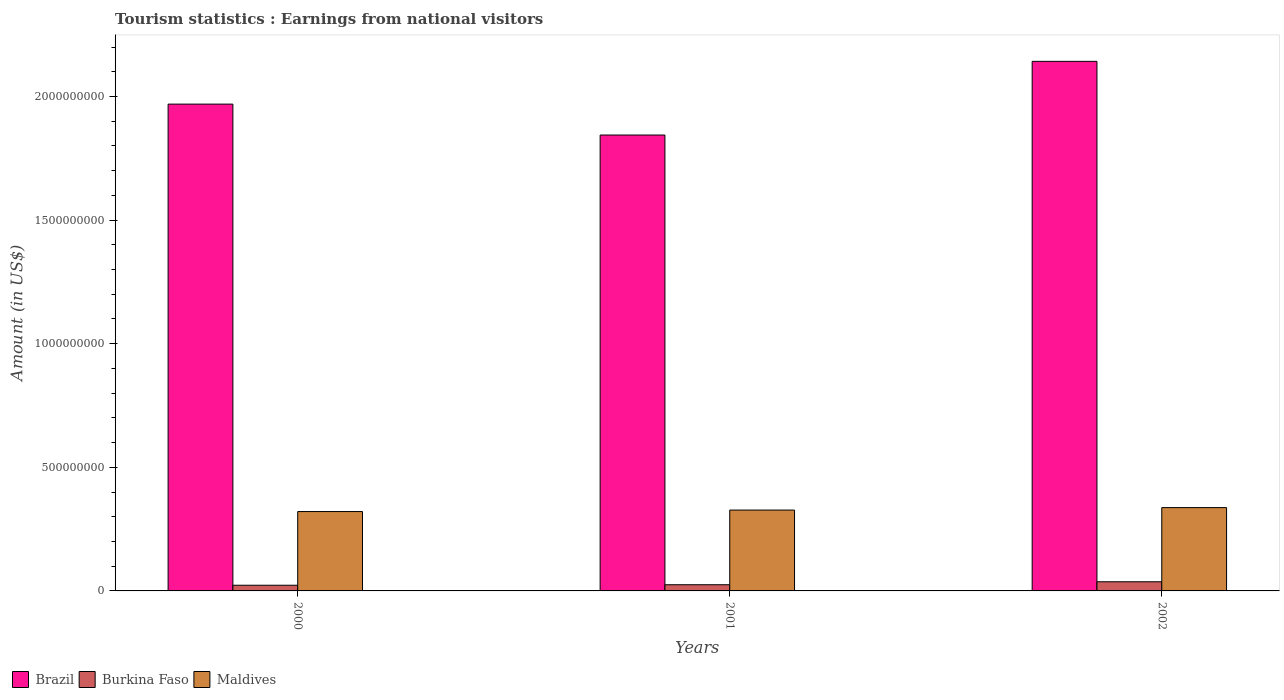How many different coloured bars are there?
Ensure brevity in your answer.  3. Are the number of bars on each tick of the X-axis equal?
Offer a terse response. Yes. How many bars are there on the 1st tick from the right?
Give a very brief answer. 3. What is the label of the 1st group of bars from the left?
Offer a terse response. 2000. In how many cases, is the number of bars for a given year not equal to the number of legend labels?
Make the answer very short. 0. What is the earnings from national visitors in Brazil in 2000?
Provide a succinct answer. 1.97e+09. Across all years, what is the maximum earnings from national visitors in Burkina Faso?
Provide a succinct answer. 3.70e+07. Across all years, what is the minimum earnings from national visitors in Maldives?
Your response must be concise. 3.21e+08. In which year was the earnings from national visitors in Brazil minimum?
Offer a very short reply. 2001. What is the total earnings from national visitors in Maldives in the graph?
Your answer should be very brief. 9.85e+08. What is the difference between the earnings from national visitors in Burkina Faso in 2000 and that in 2002?
Your answer should be very brief. -1.40e+07. What is the difference between the earnings from national visitors in Burkina Faso in 2000 and the earnings from national visitors in Brazil in 2002?
Make the answer very short. -2.12e+09. What is the average earnings from national visitors in Burkina Faso per year?
Offer a very short reply. 2.83e+07. In the year 2001, what is the difference between the earnings from national visitors in Maldives and earnings from national visitors in Brazil?
Give a very brief answer. -1.52e+09. In how many years, is the earnings from national visitors in Burkina Faso greater than 600000000 US$?
Keep it short and to the point. 0. What is the ratio of the earnings from national visitors in Brazil in 2000 to that in 2001?
Give a very brief answer. 1.07. Is the difference between the earnings from national visitors in Maldives in 2000 and 2002 greater than the difference between the earnings from national visitors in Brazil in 2000 and 2002?
Your response must be concise. Yes. What is the difference between the highest and the second highest earnings from national visitors in Brazil?
Make the answer very short. 1.73e+08. What is the difference between the highest and the lowest earnings from national visitors in Burkina Faso?
Provide a succinct answer. 1.40e+07. What does the 1st bar from the right in 2002 represents?
Provide a short and direct response. Maldives. How many years are there in the graph?
Make the answer very short. 3. What is the difference between two consecutive major ticks on the Y-axis?
Ensure brevity in your answer.  5.00e+08. How many legend labels are there?
Keep it short and to the point. 3. What is the title of the graph?
Ensure brevity in your answer.  Tourism statistics : Earnings from national visitors. What is the label or title of the Y-axis?
Ensure brevity in your answer.  Amount (in US$). What is the Amount (in US$) of Brazil in 2000?
Provide a short and direct response. 1.97e+09. What is the Amount (in US$) in Burkina Faso in 2000?
Your response must be concise. 2.30e+07. What is the Amount (in US$) in Maldives in 2000?
Ensure brevity in your answer.  3.21e+08. What is the Amount (in US$) in Brazil in 2001?
Ensure brevity in your answer.  1.84e+09. What is the Amount (in US$) of Burkina Faso in 2001?
Keep it short and to the point. 2.50e+07. What is the Amount (in US$) in Maldives in 2001?
Provide a succinct answer. 3.27e+08. What is the Amount (in US$) of Brazil in 2002?
Your answer should be compact. 2.14e+09. What is the Amount (in US$) of Burkina Faso in 2002?
Make the answer very short. 3.70e+07. What is the Amount (in US$) of Maldives in 2002?
Keep it short and to the point. 3.37e+08. Across all years, what is the maximum Amount (in US$) in Brazil?
Your response must be concise. 2.14e+09. Across all years, what is the maximum Amount (in US$) of Burkina Faso?
Make the answer very short. 3.70e+07. Across all years, what is the maximum Amount (in US$) of Maldives?
Offer a terse response. 3.37e+08. Across all years, what is the minimum Amount (in US$) in Brazil?
Your response must be concise. 1.84e+09. Across all years, what is the minimum Amount (in US$) of Burkina Faso?
Ensure brevity in your answer.  2.30e+07. Across all years, what is the minimum Amount (in US$) in Maldives?
Offer a very short reply. 3.21e+08. What is the total Amount (in US$) of Brazil in the graph?
Your response must be concise. 5.96e+09. What is the total Amount (in US$) of Burkina Faso in the graph?
Provide a short and direct response. 8.50e+07. What is the total Amount (in US$) in Maldives in the graph?
Provide a succinct answer. 9.85e+08. What is the difference between the Amount (in US$) in Brazil in 2000 and that in 2001?
Your response must be concise. 1.25e+08. What is the difference between the Amount (in US$) of Burkina Faso in 2000 and that in 2001?
Offer a terse response. -2.00e+06. What is the difference between the Amount (in US$) of Maldives in 2000 and that in 2001?
Give a very brief answer. -6.00e+06. What is the difference between the Amount (in US$) in Brazil in 2000 and that in 2002?
Give a very brief answer. -1.73e+08. What is the difference between the Amount (in US$) in Burkina Faso in 2000 and that in 2002?
Your response must be concise. -1.40e+07. What is the difference between the Amount (in US$) in Maldives in 2000 and that in 2002?
Make the answer very short. -1.60e+07. What is the difference between the Amount (in US$) of Brazil in 2001 and that in 2002?
Your answer should be very brief. -2.98e+08. What is the difference between the Amount (in US$) of Burkina Faso in 2001 and that in 2002?
Ensure brevity in your answer.  -1.20e+07. What is the difference between the Amount (in US$) in Maldives in 2001 and that in 2002?
Offer a terse response. -1.00e+07. What is the difference between the Amount (in US$) in Brazil in 2000 and the Amount (in US$) in Burkina Faso in 2001?
Keep it short and to the point. 1.94e+09. What is the difference between the Amount (in US$) in Brazil in 2000 and the Amount (in US$) in Maldives in 2001?
Your answer should be very brief. 1.64e+09. What is the difference between the Amount (in US$) in Burkina Faso in 2000 and the Amount (in US$) in Maldives in 2001?
Your response must be concise. -3.04e+08. What is the difference between the Amount (in US$) of Brazil in 2000 and the Amount (in US$) of Burkina Faso in 2002?
Make the answer very short. 1.93e+09. What is the difference between the Amount (in US$) of Brazil in 2000 and the Amount (in US$) of Maldives in 2002?
Provide a succinct answer. 1.63e+09. What is the difference between the Amount (in US$) of Burkina Faso in 2000 and the Amount (in US$) of Maldives in 2002?
Keep it short and to the point. -3.14e+08. What is the difference between the Amount (in US$) in Brazil in 2001 and the Amount (in US$) in Burkina Faso in 2002?
Make the answer very short. 1.81e+09. What is the difference between the Amount (in US$) of Brazil in 2001 and the Amount (in US$) of Maldives in 2002?
Ensure brevity in your answer.  1.51e+09. What is the difference between the Amount (in US$) of Burkina Faso in 2001 and the Amount (in US$) of Maldives in 2002?
Your response must be concise. -3.12e+08. What is the average Amount (in US$) in Brazil per year?
Keep it short and to the point. 1.98e+09. What is the average Amount (in US$) in Burkina Faso per year?
Provide a short and direct response. 2.83e+07. What is the average Amount (in US$) of Maldives per year?
Make the answer very short. 3.28e+08. In the year 2000, what is the difference between the Amount (in US$) in Brazil and Amount (in US$) in Burkina Faso?
Make the answer very short. 1.95e+09. In the year 2000, what is the difference between the Amount (in US$) in Brazil and Amount (in US$) in Maldives?
Ensure brevity in your answer.  1.65e+09. In the year 2000, what is the difference between the Amount (in US$) of Burkina Faso and Amount (in US$) of Maldives?
Keep it short and to the point. -2.98e+08. In the year 2001, what is the difference between the Amount (in US$) in Brazil and Amount (in US$) in Burkina Faso?
Provide a succinct answer. 1.82e+09. In the year 2001, what is the difference between the Amount (in US$) in Brazil and Amount (in US$) in Maldives?
Provide a succinct answer. 1.52e+09. In the year 2001, what is the difference between the Amount (in US$) of Burkina Faso and Amount (in US$) of Maldives?
Ensure brevity in your answer.  -3.02e+08. In the year 2002, what is the difference between the Amount (in US$) in Brazil and Amount (in US$) in Burkina Faso?
Offer a very short reply. 2.10e+09. In the year 2002, what is the difference between the Amount (in US$) in Brazil and Amount (in US$) in Maldives?
Offer a terse response. 1.80e+09. In the year 2002, what is the difference between the Amount (in US$) of Burkina Faso and Amount (in US$) of Maldives?
Provide a succinct answer. -3.00e+08. What is the ratio of the Amount (in US$) in Brazil in 2000 to that in 2001?
Your answer should be very brief. 1.07. What is the ratio of the Amount (in US$) of Burkina Faso in 2000 to that in 2001?
Provide a succinct answer. 0.92. What is the ratio of the Amount (in US$) of Maldives in 2000 to that in 2001?
Ensure brevity in your answer.  0.98. What is the ratio of the Amount (in US$) in Brazil in 2000 to that in 2002?
Provide a short and direct response. 0.92. What is the ratio of the Amount (in US$) of Burkina Faso in 2000 to that in 2002?
Give a very brief answer. 0.62. What is the ratio of the Amount (in US$) of Maldives in 2000 to that in 2002?
Keep it short and to the point. 0.95. What is the ratio of the Amount (in US$) of Brazil in 2001 to that in 2002?
Your answer should be compact. 0.86. What is the ratio of the Amount (in US$) in Burkina Faso in 2001 to that in 2002?
Provide a succinct answer. 0.68. What is the ratio of the Amount (in US$) in Maldives in 2001 to that in 2002?
Keep it short and to the point. 0.97. What is the difference between the highest and the second highest Amount (in US$) of Brazil?
Keep it short and to the point. 1.73e+08. What is the difference between the highest and the second highest Amount (in US$) of Burkina Faso?
Provide a succinct answer. 1.20e+07. What is the difference between the highest and the second highest Amount (in US$) of Maldives?
Make the answer very short. 1.00e+07. What is the difference between the highest and the lowest Amount (in US$) in Brazil?
Your answer should be compact. 2.98e+08. What is the difference between the highest and the lowest Amount (in US$) of Burkina Faso?
Give a very brief answer. 1.40e+07. What is the difference between the highest and the lowest Amount (in US$) in Maldives?
Your answer should be very brief. 1.60e+07. 